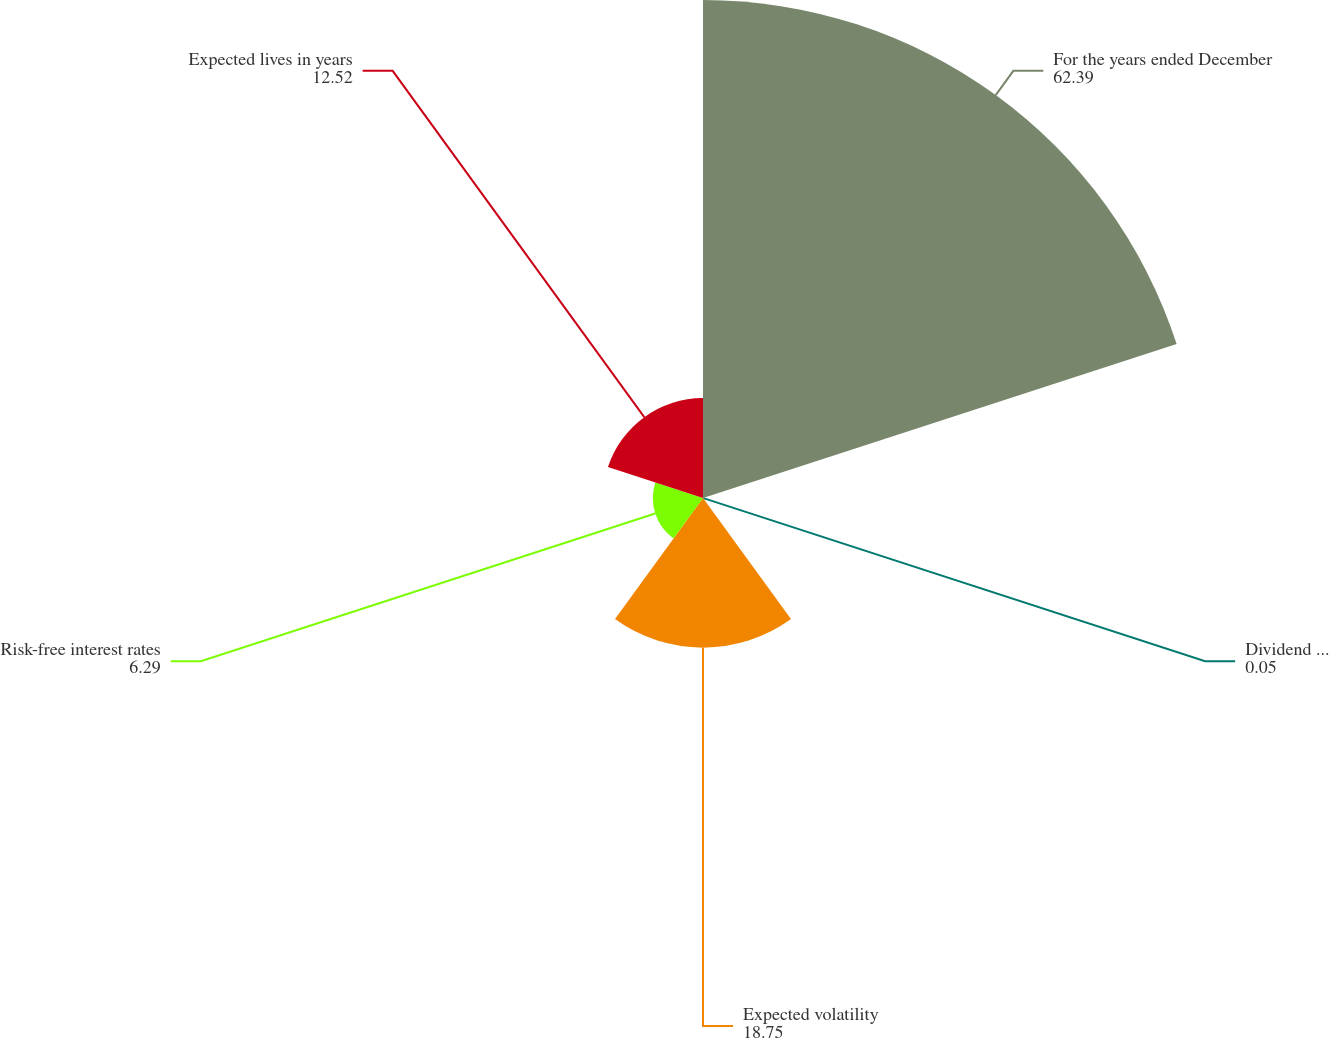<chart> <loc_0><loc_0><loc_500><loc_500><pie_chart><fcel>For the years ended December<fcel>Dividend yields<fcel>Expected volatility<fcel>Risk-free interest rates<fcel>Expected lives in years<nl><fcel>62.39%<fcel>0.05%<fcel>18.75%<fcel>6.29%<fcel>12.52%<nl></chart> 